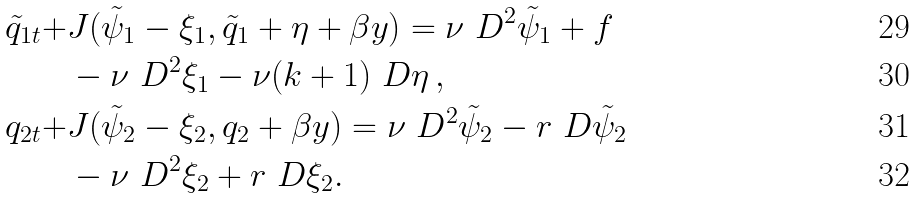Convert formula to latex. <formula><loc_0><loc_0><loc_500><loc_500>\tilde { q } _ { 1 t } + & J ( \tilde { \psi } _ { 1 } - \xi _ { 1 } , \tilde { q } _ { 1 } + \eta + \beta y ) = \nu \ D ^ { 2 } \tilde { \psi } _ { 1 } + f \\ & - \nu \ D ^ { 2 } \xi _ { 1 } - \nu ( k + 1 ) \ D \eta \, , \\ q _ { 2 t } + & J ( \tilde { \psi } _ { 2 } - \xi _ { 2 } , q _ { 2 } + \beta y ) = \nu \ D ^ { 2 } \tilde { \psi } _ { 2 } - r \ D \tilde { \psi } _ { 2 } \\ & - \nu \ D ^ { 2 } \xi _ { 2 } + r \ D \xi _ { 2 } .</formula> 